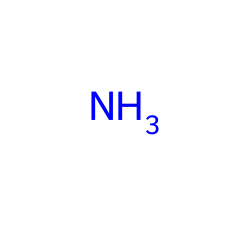What is the molecular formula of ammonia? The SMILES representation indicates there is one nitrogen atom (N) and three hydrogen atoms (H). Therefore, the molecular formula is NH3.
Answer: NH3 How many hydrogen atoms are in ammonia? The SMILES representation shows that ammonia consists of one nitrogen atom and three hydrogen atoms, thus there are three hydrogen atoms.
Answer: 3 What type of bonding is present in ammonia? Ammonia has covalent bonds between the nitrogen atom and the three hydrogen atoms, as it involves the sharing of electrons.
Answer: covalent What is the state of ammonia at room temperature? Ammonia is typically a gas at room temperature, as is typical for many small molecular compounds with low molecular weights.
Answer: gas Why is ammonia used as a refrigerant? Ammonia has high thermal efficiency and excellent cooling properties, making it effective for heat absorption and transfer in refrigeration systems.
Answer: high thermal efficiency How many total atoms are in a molecule of ammonia? Ammonia consists of one nitrogen atom and three hydrogen atoms, making a total of four atoms in one molecule.
Answer: 4 What is a unique property of ammonia as a refrigerant? Ammonia has a low boiling point, which allows it to evaporate easily at lower temperatures, making it suitable for refrigeration cycles.
Answer: low boiling point 